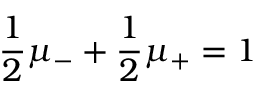Convert formula to latex. <formula><loc_0><loc_0><loc_500><loc_500>\frac { 1 } { 2 } \mu _ { - } + \frac { 1 } { 2 } \mu _ { + } = 1</formula> 